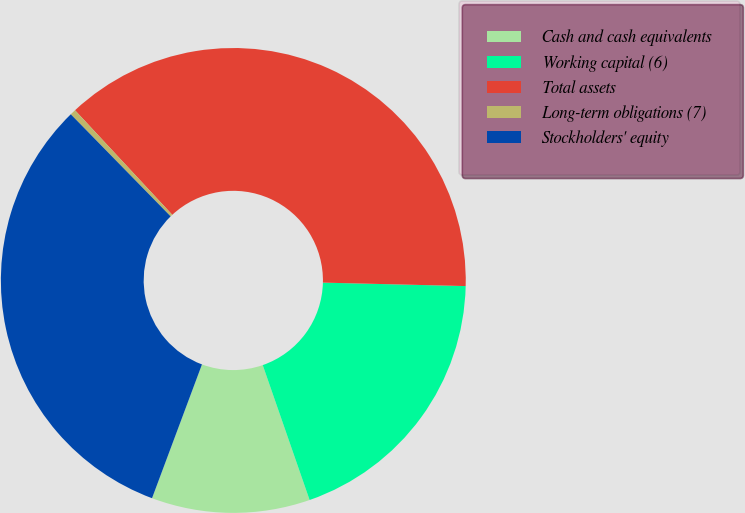<chart> <loc_0><loc_0><loc_500><loc_500><pie_chart><fcel>Cash and cash equivalents<fcel>Working capital (6)<fcel>Total assets<fcel>Long-term obligations (7)<fcel>Stockholders' equity<nl><fcel>11.01%<fcel>19.29%<fcel>37.31%<fcel>0.4%<fcel>31.99%<nl></chart> 